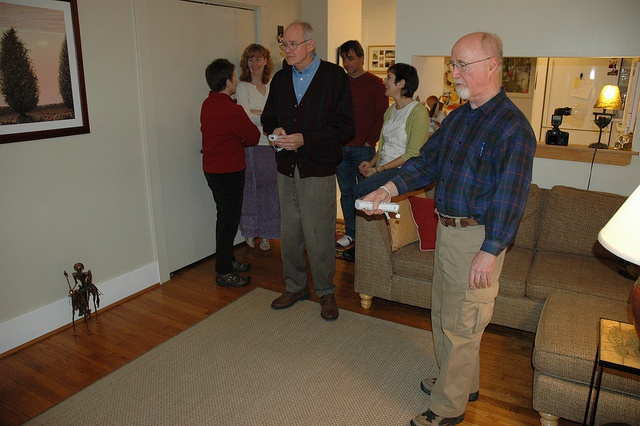Describe the objects in this image and their specific colors. I can see people in gray, black, and navy tones, couch in gray, maroon, and black tones, people in gray, black, and brown tones, couch in gray and olive tones, and people in gray, black, and maroon tones in this image. 